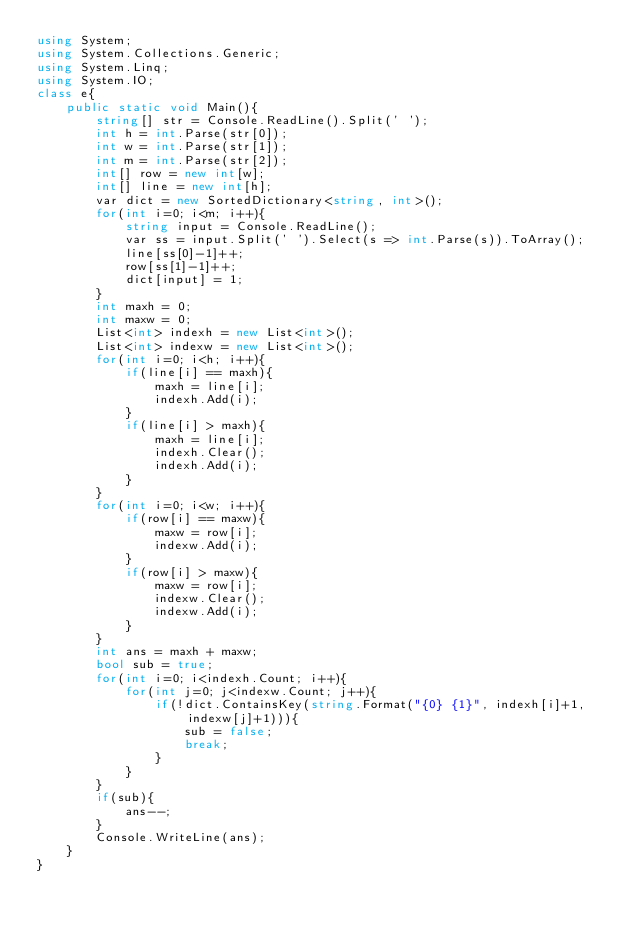Convert code to text. <code><loc_0><loc_0><loc_500><loc_500><_C#_>using System;
using System.Collections.Generic;
using System.Linq;
using System.IO;
class e{
    public static void Main(){
        string[] str = Console.ReadLine().Split(' ');
        int h = int.Parse(str[0]);
        int w = int.Parse(str[1]);
        int m = int.Parse(str[2]);
        int[] row = new int[w];
        int[] line = new int[h];
        var dict = new SortedDictionary<string, int>();
        for(int i=0; i<m; i++){
            string input = Console.ReadLine();
            var ss = input.Split(' ').Select(s => int.Parse(s)).ToArray();
            line[ss[0]-1]++;
            row[ss[1]-1]++;
            dict[input] = 1;
        }
        int maxh = 0;
        int maxw = 0;
        List<int> indexh = new List<int>();
        List<int> indexw = new List<int>();
        for(int i=0; i<h; i++){
            if(line[i] == maxh){
                maxh = line[i];
                indexh.Add(i);
            }
            if(line[i] > maxh){
                maxh = line[i];
                indexh.Clear();
                indexh.Add(i);
            }
        }
        for(int i=0; i<w; i++){
            if(row[i] == maxw){
                maxw = row[i];
                indexw.Add(i);
            }
            if(row[i] > maxw){
                maxw = row[i];
                indexw.Clear();
                indexw.Add(i);
            }
        }
        int ans = maxh + maxw;
        bool sub = true;
        for(int i=0; i<indexh.Count; i++){
            for(int j=0; j<indexw.Count; j++){
                if(!dict.ContainsKey(string.Format("{0} {1}", indexh[i]+1, indexw[j]+1))){
                    sub = false;
                    break;
                }
            }
        }
        if(sub){
            ans--;
        }
        Console.WriteLine(ans);
    }
}
</code> 